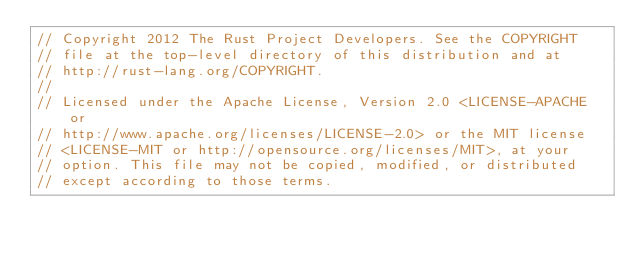Convert code to text. <code><loc_0><loc_0><loc_500><loc_500><_Rust_>// Copyright 2012 The Rust Project Developers. See the COPYRIGHT
// file at the top-level directory of this distribution and at
// http://rust-lang.org/COPYRIGHT.
//
// Licensed under the Apache License, Version 2.0 <LICENSE-APACHE or
// http://www.apache.org/licenses/LICENSE-2.0> or the MIT license
// <LICENSE-MIT or http://opensource.org/licenses/MIT>, at your
// option. This file may not be copied, modified, or distributed
// except according to those terms.
</code> 